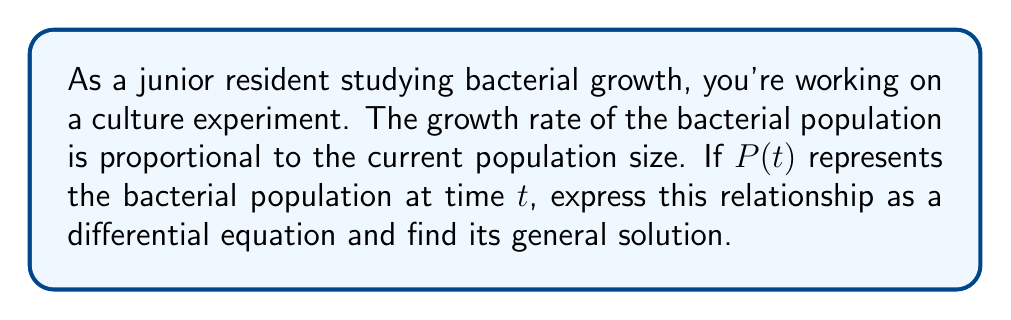Show me your answer to this math problem. Let's approach this step-by-step:

1) First, we need to express the given information as a differential equation. The growth rate (rate of change of population with respect to time) is proportional to the current population. Mathematically, this can be written as:

   $$\frac{dP}{dt} = kP$$

   where $k$ is the proportionality constant (growth rate constant).

2) This is a first-order linear homogeneous differential equation.

3) To solve this, we can use the separation of variables method:

   $$\frac{dP}{P} = k dt$$

4) Integrating both sides:

   $$\int \frac{dP}{P} = \int k dt$$

5) This gives us:

   $$\ln|P| = kt + C$$

   where $C$ is the constant of integration.

6) Now, we can exponentiate both sides:

   $$e^{\ln|P|} = e^{kt + C}$$

7) Simplifying:

   $$P = e^C \cdot e^{kt}$$

8) We can replace $e^C$ with a new constant $A$, as $e^C$ is just some positive constant:

   $$P = A e^{kt}$$

This is the general solution to the differential equation.
Answer: The general solution is $P(t) = A e^{kt}$, where $A$ and $k$ are constants, with $A > 0$ representing the initial population and $k$ representing the growth rate constant. 